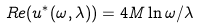Convert formula to latex. <formula><loc_0><loc_0><loc_500><loc_500>R e ( u ^ { * } ( \omega , \lambda ) ) = 4 M \ln \omega / \lambda</formula> 